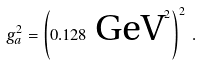Convert formula to latex. <formula><loc_0><loc_0><loc_500><loc_500>g _ { a } ^ { 2 } = \left ( 0 . 1 2 8 \text { GeV} ^ { 2 } \right ) ^ { 2 } \, .</formula> 